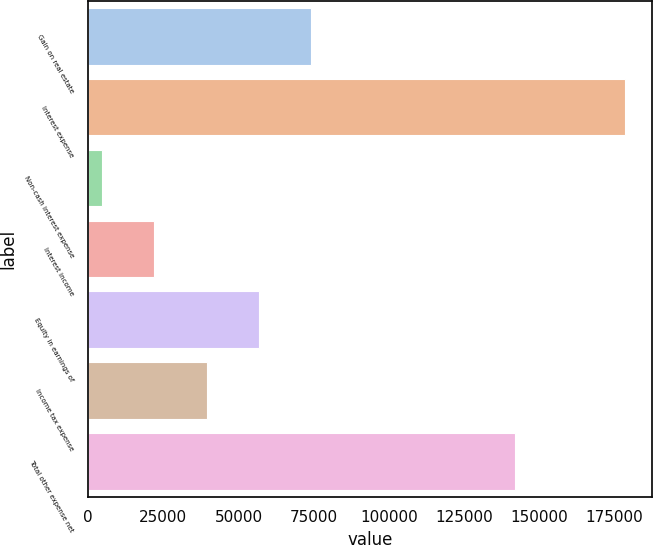Convert chart to OTSL. <chart><loc_0><loc_0><loc_500><loc_500><bar_chart><fcel>Gain on real estate<fcel>Interest expense<fcel>Non-cash interest expense<fcel>Interest income<fcel>Equity in earnings of<fcel>Income tax expense<fcel>Total other expense net<nl><fcel>74186.6<fcel>178436<fcel>4687<fcel>22061.9<fcel>56811.7<fcel>39436.8<fcel>141816<nl></chart> 